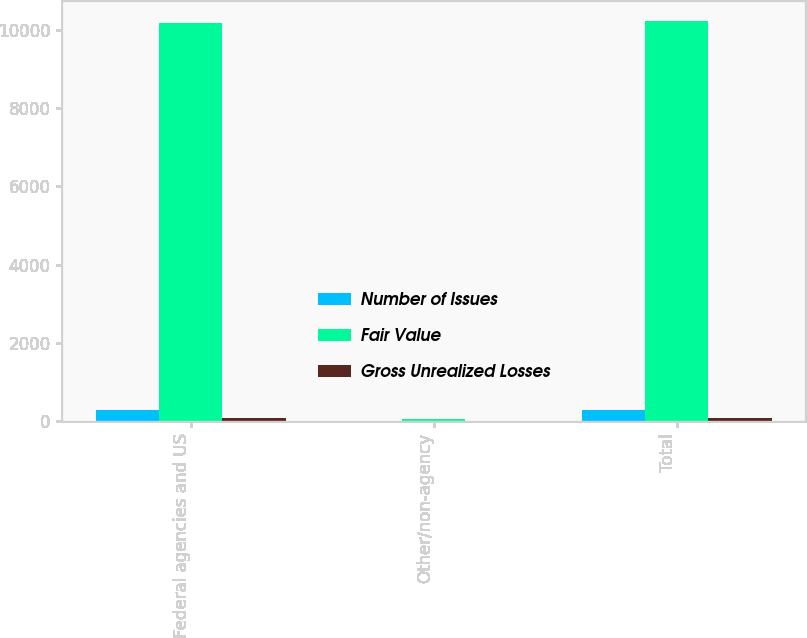Convert chart to OTSL. <chart><loc_0><loc_0><loc_500><loc_500><stacked_bar_chart><ecel><fcel>Federal agencies and US<fcel>Other/non-agency<fcel>Total<nl><fcel>Number of Issues<fcel>294<fcel>6<fcel>300<nl><fcel>Fair Value<fcel>10163<fcel>55<fcel>10218<nl><fcel>Gross Unrealized Losses<fcel>97<fcel>1<fcel>98<nl></chart> 